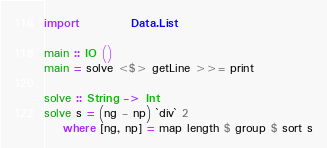Convert code to text. <code><loc_0><loc_0><loc_500><loc_500><_Haskell_>import           Data.List

main :: IO ()
main = solve <$> getLine >>= print

solve :: String -> Int
solve s = (ng - np) `div` 2
    where [ng, np] = map length $ group $ sort s
</code> 